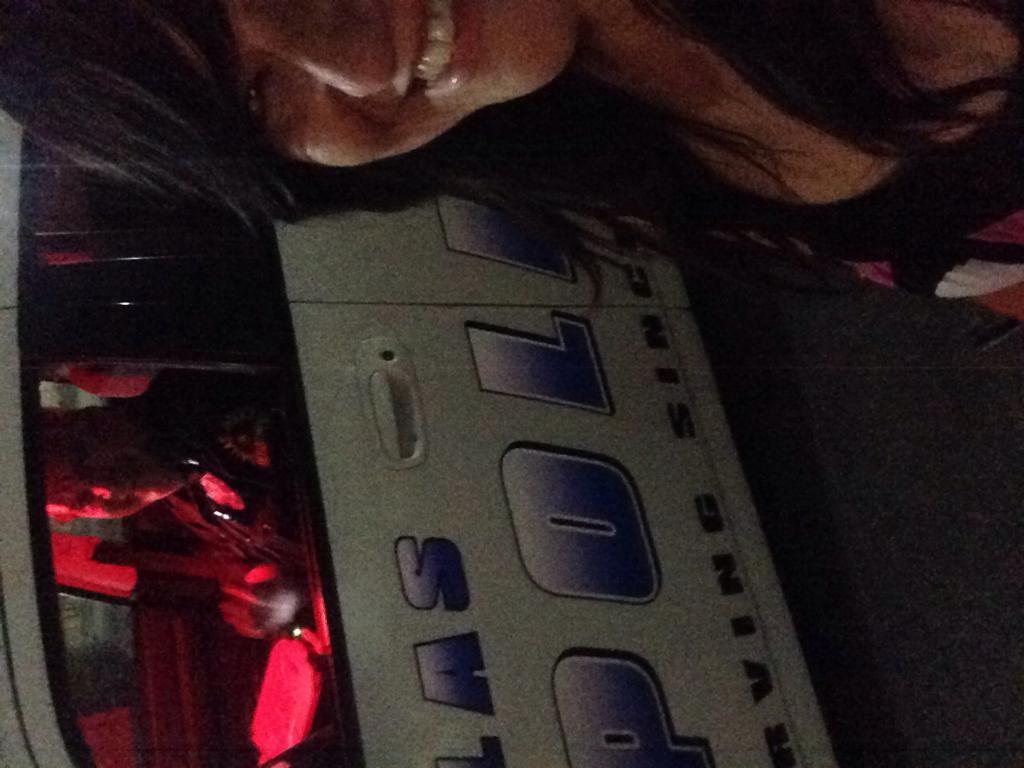Describe this image in one or two sentences. In this image on the top there is one woman who is smiling and at the bottom there is one vehicle, in that vehicle there is one person who is sitting and smiling. 